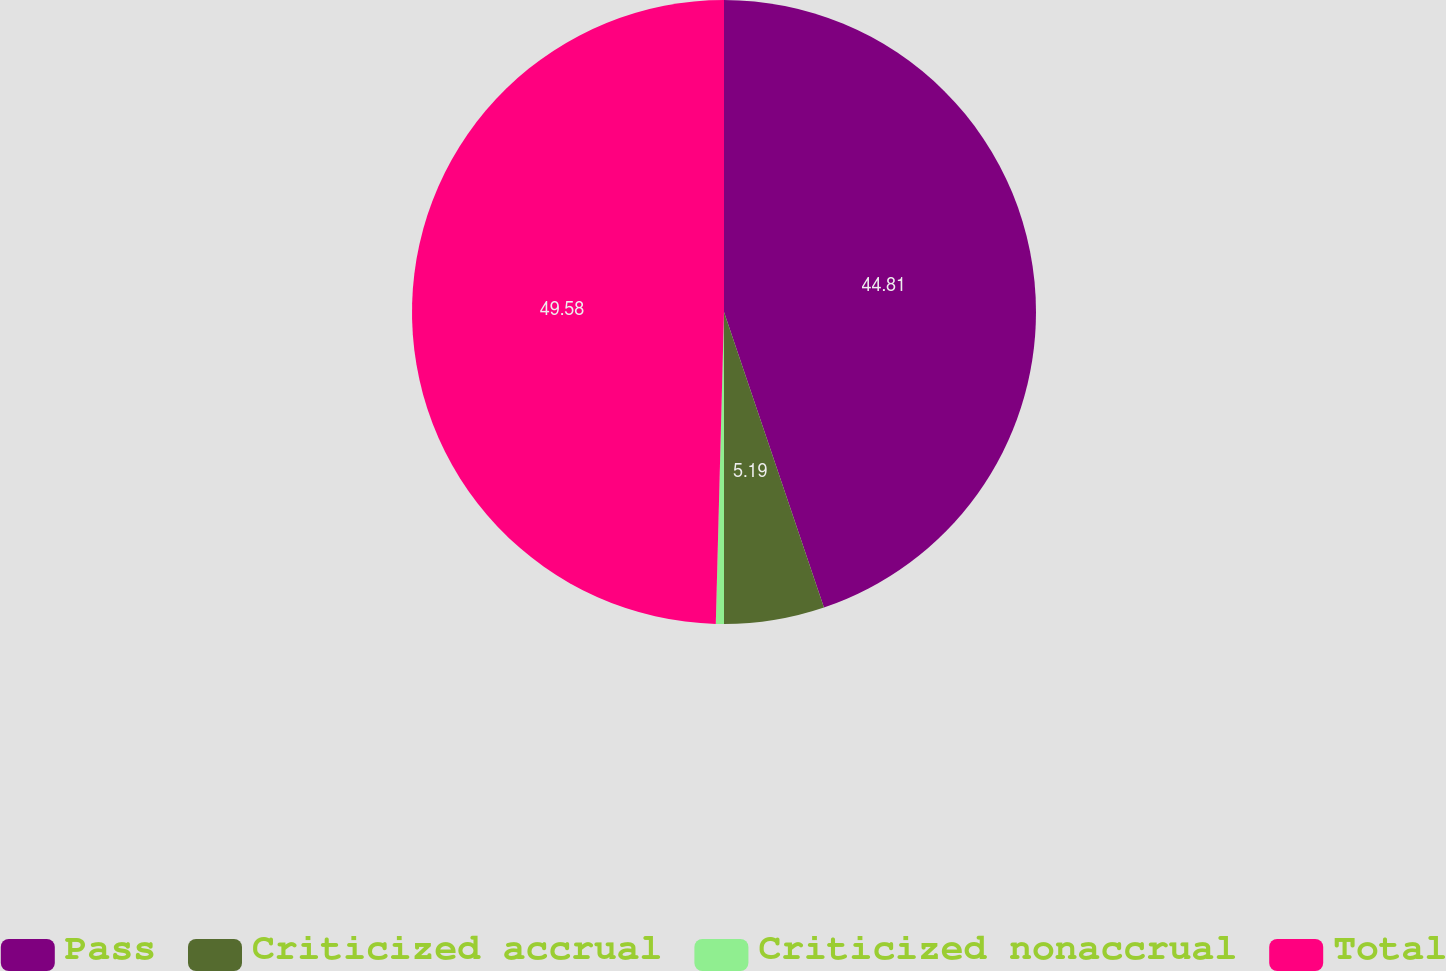<chart> <loc_0><loc_0><loc_500><loc_500><pie_chart><fcel>Pass<fcel>Criticized accrual<fcel>Criticized nonaccrual<fcel>Total<nl><fcel>44.81%<fcel>5.19%<fcel>0.42%<fcel>49.58%<nl></chart> 